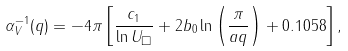Convert formula to latex. <formula><loc_0><loc_0><loc_500><loc_500>\alpha _ { V } ^ { - 1 } ( q ) = - 4 \pi \left [ \frac { c _ { 1 } } { \ln U _ { \Box } } + 2 b _ { 0 } \ln \left ( \frac { \pi } { a q } \right ) + 0 . 1 0 5 8 \right ] ,</formula> 